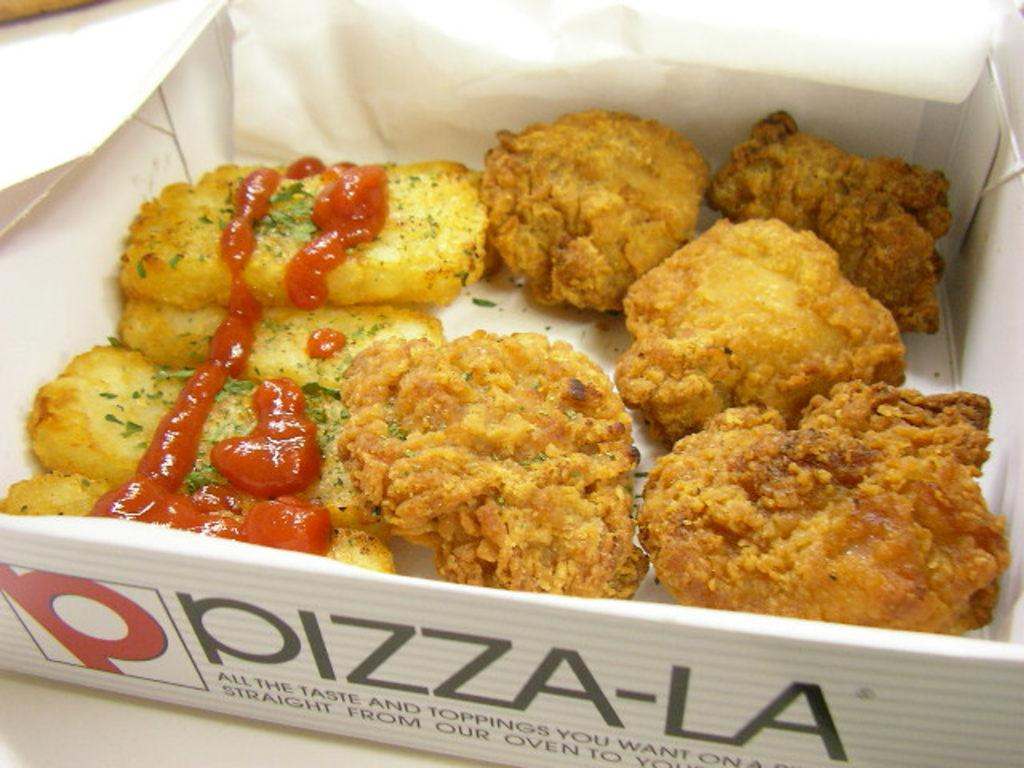What type of food is visible in the image? There is food in the image, but the specific type is not mentioned. What accompanies the food in the image? There is sauce in the image. How are the food and sauce contained in the image? The food and sauce are in a cardboard box. What can be found on the cardboard box? The cardboard box has text on it. Where is the cardboard box located in the image? The cardboard box is placed on a surface. What game is being played in the image? There is no game or play activity depicted in the image; it features food, sauce, and a cardboard box. What level of difficulty is associated with the food in the image? The image does not provide any information about the difficulty level of the food. 